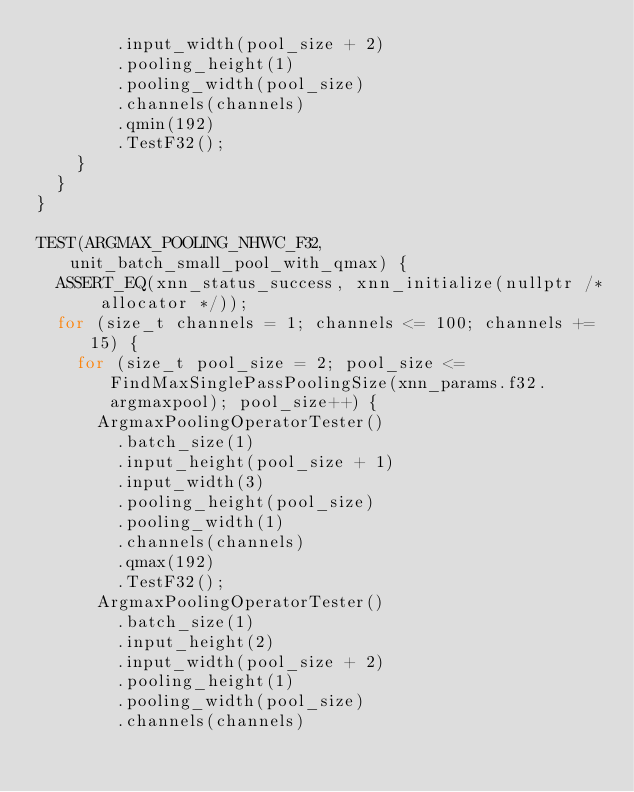Convert code to text. <code><loc_0><loc_0><loc_500><loc_500><_C++_>        .input_width(pool_size + 2)
        .pooling_height(1)
        .pooling_width(pool_size)
        .channels(channels)
        .qmin(192)
        .TestF32();
    }
  }
}

TEST(ARGMAX_POOLING_NHWC_F32, unit_batch_small_pool_with_qmax) {
  ASSERT_EQ(xnn_status_success, xnn_initialize(nullptr /* allocator */));
  for (size_t channels = 1; channels <= 100; channels += 15) {
    for (size_t pool_size = 2; pool_size <= FindMaxSinglePassPoolingSize(xnn_params.f32.argmaxpool); pool_size++) {
      ArgmaxPoolingOperatorTester()
        .batch_size(1)
        .input_height(pool_size + 1)
        .input_width(3)
        .pooling_height(pool_size)
        .pooling_width(1)
        .channels(channels)
        .qmax(192)
        .TestF32();
      ArgmaxPoolingOperatorTester()
        .batch_size(1)
        .input_height(2)
        .input_width(pool_size + 2)
        .pooling_height(1)
        .pooling_width(pool_size)
        .channels(channels)</code> 